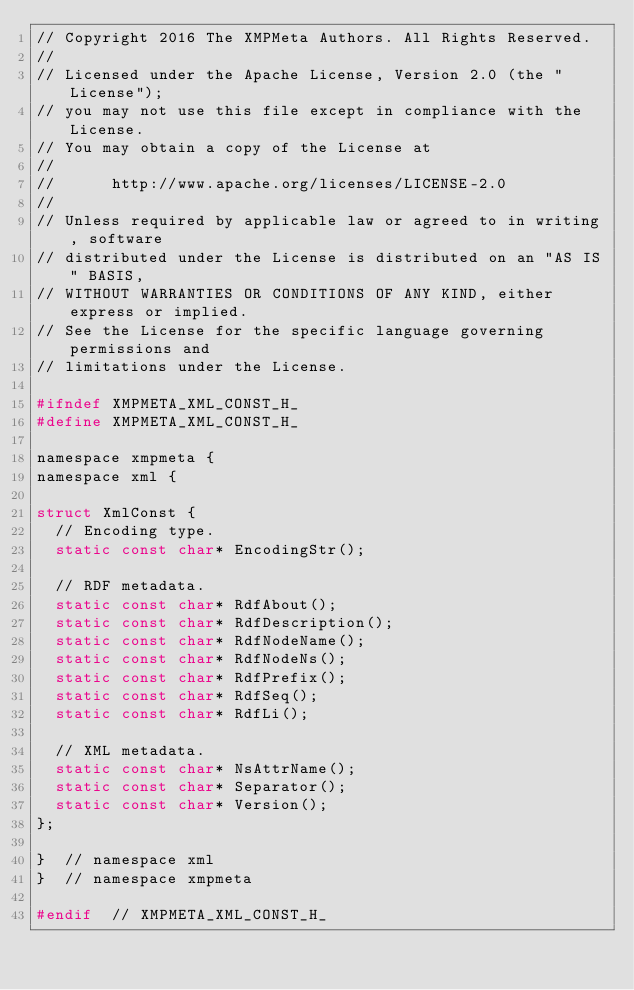<code> <loc_0><loc_0><loc_500><loc_500><_C_>// Copyright 2016 The XMPMeta Authors. All Rights Reserved.
//
// Licensed under the Apache License, Version 2.0 (the "License");
// you may not use this file except in compliance with the License.
// You may obtain a copy of the License at
//
//      http://www.apache.org/licenses/LICENSE-2.0
//
// Unless required by applicable law or agreed to in writing, software
// distributed under the License is distributed on an "AS IS" BASIS,
// WITHOUT WARRANTIES OR CONDITIONS OF ANY KIND, either express or implied.
// See the License for the specific language governing permissions and
// limitations under the License.

#ifndef XMPMETA_XML_CONST_H_
#define XMPMETA_XML_CONST_H_

namespace xmpmeta {
namespace xml {

struct XmlConst {
  // Encoding type.
  static const char* EncodingStr();

  // RDF metadata.
  static const char* RdfAbout();
  static const char* RdfDescription();
  static const char* RdfNodeName();
  static const char* RdfNodeNs();
  static const char* RdfPrefix();
  static const char* RdfSeq();
  static const char* RdfLi();

  // XML metadata.
  static const char* NsAttrName();
  static const char* Separator();
  static const char* Version();
};

}  // namespace xml
}  // namespace xmpmeta

#endif  // XMPMETA_XML_CONST_H_
</code> 